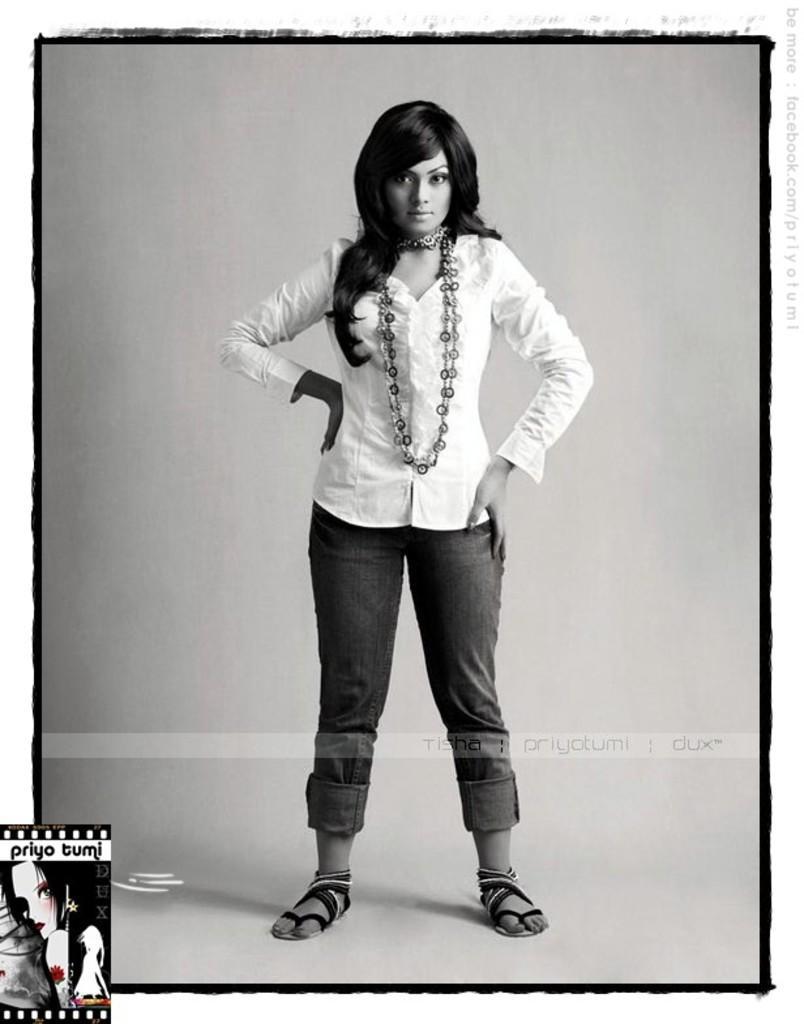Can you describe this image briefly? In the center of the picture there is a woman standing, wearing a white dress. The picture has black frame. At the bottom there is a logo. 